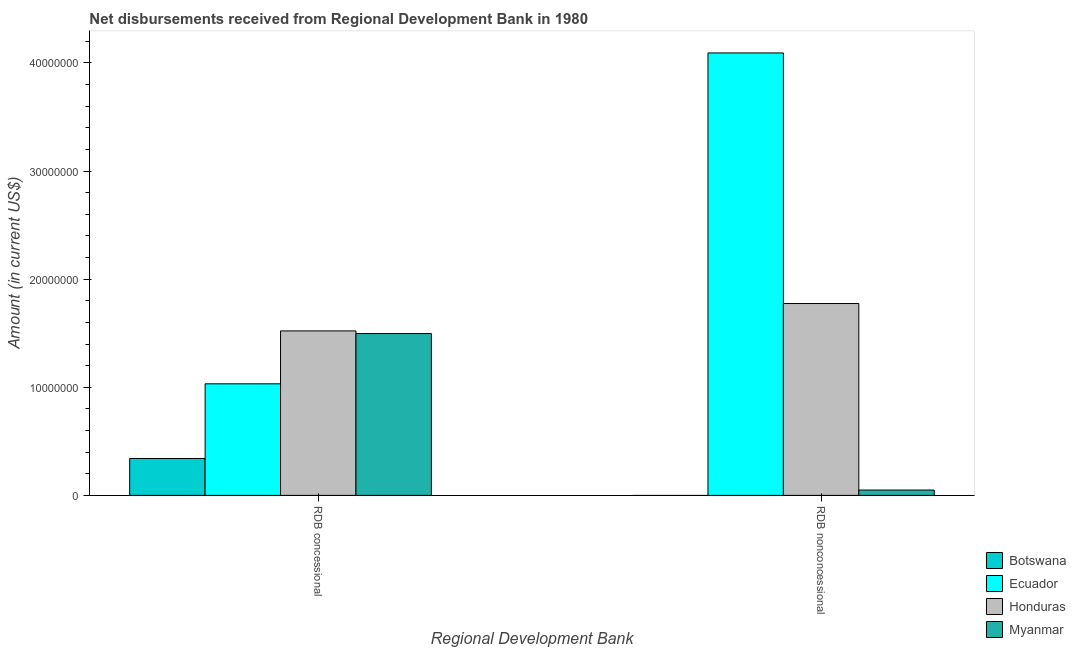How many bars are there on the 1st tick from the left?
Provide a short and direct response. 4. What is the label of the 2nd group of bars from the left?
Keep it short and to the point. RDB nonconcessional. What is the net concessional disbursements from rdb in Botswana?
Provide a succinct answer. 3.41e+06. Across all countries, what is the maximum net non concessional disbursements from rdb?
Your response must be concise. 4.09e+07. In which country was the net concessional disbursements from rdb maximum?
Ensure brevity in your answer.  Honduras. What is the total net concessional disbursements from rdb in the graph?
Make the answer very short. 4.39e+07. What is the difference between the net non concessional disbursements from rdb in Myanmar and that in Honduras?
Offer a very short reply. -1.72e+07. What is the difference between the net concessional disbursements from rdb in Botswana and the net non concessional disbursements from rdb in Ecuador?
Offer a very short reply. -3.75e+07. What is the average net non concessional disbursements from rdb per country?
Your response must be concise. 1.48e+07. What is the difference between the net concessional disbursements from rdb and net non concessional disbursements from rdb in Myanmar?
Your response must be concise. 1.45e+07. In how many countries, is the net concessional disbursements from rdb greater than 18000000 US$?
Your response must be concise. 0. What is the ratio of the net concessional disbursements from rdb in Ecuador to that in Myanmar?
Make the answer very short. 0.69. Is the net concessional disbursements from rdb in Botswana less than that in Ecuador?
Make the answer very short. Yes. How many bars are there?
Ensure brevity in your answer.  7. How many countries are there in the graph?
Give a very brief answer. 4. What is the difference between two consecutive major ticks on the Y-axis?
Provide a short and direct response. 1.00e+07. Where does the legend appear in the graph?
Your response must be concise. Bottom right. What is the title of the graph?
Offer a terse response. Net disbursements received from Regional Development Bank in 1980. Does "Zambia" appear as one of the legend labels in the graph?
Offer a terse response. No. What is the label or title of the X-axis?
Your response must be concise. Regional Development Bank. What is the Amount (in current US$) in Botswana in RDB concessional?
Make the answer very short. 3.41e+06. What is the Amount (in current US$) in Ecuador in RDB concessional?
Provide a succinct answer. 1.03e+07. What is the Amount (in current US$) in Honduras in RDB concessional?
Offer a terse response. 1.52e+07. What is the Amount (in current US$) of Myanmar in RDB concessional?
Your answer should be very brief. 1.50e+07. What is the Amount (in current US$) in Botswana in RDB nonconcessional?
Make the answer very short. 0. What is the Amount (in current US$) of Ecuador in RDB nonconcessional?
Offer a terse response. 4.09e+07. What is the Amount (in current US$) of Honduras in RDB nonconcessional?
Offer a very short reply. 1.77e+07. What is the Amount (in current US$) of Myanmar in RDB nonconcessional?
Your answer should be very brief. 4.94e+05. Across all Regional Development Bank, what is the maximum Amount (in current US$) in Botswana?
Offer a very short reply. 3.41e+06. Across all Regional Development Bank, what is the maximum Amount (in current US$) of Ecuador?
Give a very brief answer. 4.09e+07. Across all Regional Development Bank, what is the maximum Amount (in current US$) of Honduras?
Ensure brevity in your answer.  1.77e+07. Across all Regional Development Bank, what is the maximum Amount (in current US$) of Myanmar?
Ensure brevity in your answer.  1.50e+07. Across all Regional Development Bank, what is the minimum Amount (in current US$) in Ecuador?
Keep it short and to the point. 1.03e+07. Across all Regional Development Bank, what is the minimum Amount (in current US$) in Honduras?
Provide a succinct answer. 1.52e+07. Across all Regional Development Bank, what is the minimum Amount (in current US$) in Myanmar?
Your response must be concise. 4.94e+05. What is the total Amount (in current US$) in Botswana in the graph?
Your answer should be compact. 3.41e+06. What is the total Amount (in current US$) in Ecuador in the graph?
Ensure brevity in your answer.  5.12e+07. What is the total Amount (in current US$) of Honduras in the graph?
Your response must be concise. 3.30e+07. What is the total Amount (in current US$) in Myanmar in the graph?
Your answer should be compact. 1.55e+07. What is the difference between the Amount (in current US$) in Ecuador in RDB concessional and that in RDB nonconcessional?
Keep it short and to the point. -3.06e+07. What is the difference between the Amount (in current US$) in Honduras in RDB concessional and that in RDB nonconcessional?
Offer a terse response. -2.53e+06. What is the difference between the Amount (in current US$) of Myanmar in RDB concessional and that in RDB nonconcessional?
Provide a succinct answer. 1.45e+07. What is the difference between the Amount (in current US$) in Botswana in RDB concessional and the Amount (in current US$) in Ecuador in RDB nonconcessional?
Make the answer very short. -3.75e+07. What is the difference between the Amount (in current US$) of Botswana in RDB concessional and the Amount (in current US$) of Honduras in RDB nonconcessional?
Offer a very short reply. -1.43e+07. What is the difference between the Amount (in current US$) of Botswana in RDB concessional and the Amount (in current US$) of Myanmar in RDB nonconcessional?
Your response must be concise. 2.92e+06. What is the difference between the Amount (in current US$) of Ecuador in RDB concessional and the Amount (in current US$) of Honduras in RDB nonconcessional?
Provide a short and direct response. -7.43e+06. What is the difference between the Amount (in current US$) of Ecuador in RDB concessional and the Amount (in current US$) of Myanmar in RDB nonconcessional?
Provide a succinct answer. 9.82e+06. What is the difference between the Amount (in current US$) of Honduras in RDB concessional and the Amount (in current US$) of Myanmar in RDB nonconcessional?
Offer a terse response. 1.47e+07. What is the average Amount (in current US$) of Botswana per Regional Development Bank?
Give a very brief answer. 1.71e+06. What is the average Amount (in current US$) in Ecuador per Regional Development Bank?
Your response must be concise. 2.56e+07. What is the average Amount (in current US$) in Honduras per Regional Development Bank?
Offer a terse response. 1.65e+07. What is the average Amount (in current US$) in Myanmar per Regional Development Bank?
Your answer should be compact. 7.73e+06. What is the difference between the Amount (in current US$) in Botswana and Amount (in current US$) in Ecuador in RDB concessional?
Ensure brevity in your answer.  -6.91e+06. What is the difference between the Amount (in current US$) in Botswana and Amount (in current US$) in Honduras in RDB concessional?
Provide a succinct answer. -1.18e+07. What is the difference between the Amount (in current US$) in Botswana and Amount (in current US$) in Myanmar in RDB concessional?
Give a very brief answer. -1.16e+07. What is the difference between the Amount (in current US$) of Ecuador and Amount (in current US$) of Honduras in RDB concessional?
Your answer should be very brief. -4.89e+06. What is the difference between the Amount (in current US$) in Ecuador and Amount (in current US$) in Myanmar in RDB concessional?
Provide a succinct answer. -4.65e+06. What is the difference between the Amount (in current US$) of Honduras and Amount (in current US$) of Myanmar in RDB concessional?
Offer a very short reply. 2.43e+05. What is the difference between the Amount (in current US$) of Ecuador and Amount (in current US$) of Honduras in RDB nonconcessional?
Offer a very short reply. 2.32e+07. What is the difference between the Amount (in current US$) in Ecuador and Amount (in current US$) in Myanmar in RDB nonconcessional?
Offer a very short reply. 4.04e+07. What is the difference between the Amount (in current US$) in Honduras and Amount (in current US$) in Myanmar in RDB nonconcessional?
Offer a very short reply. 1.72e+07. What is the ratio of the Amount (in current US$) of Ecuador in RDB concessional to that in RDB nonconcessional?
Make the answer very short. 0.25. What is the ratio of the Amount (in current US$) of Honduras in RDB concessional to that in RDB nonconcessional?
Offer a terse response. 0.86. What is the ratio of the Amount (in current US$) of Myanmar in RDB concessional to that in RDB nonconcessional?
Offer a very short reply. 30.3. What is the difference between the highest and the second highest Amount (in current US$) of Ecuador?
Give a very brief answer. 3.06e+07. What is the difference between the highest and the second highest Amount (in current US$) in Honduras?
Offer a very short reply. 2.53e+06. What is the difference between the highest and the second highest Amount (in current US$) of Myanmar?
Make the answer very short. 1.45e+07. What is the difference between the highest and the lowest Amount (in current US$) of Botswana?
Your response must be concise. 3.41e+06. What is the difference between the highest and the lowest Amount (in current US$) in Ecuador?
Your answer should be very brief. 3.06e+07. What is the difference between the highest and the lowest Amount (in current US$) of Honduras?
Provide a succinct answer. 2.53e+06. What is the difference between the highest and the lowest Amount (in current US$) in Myanmar?
Offer a terse response. 1.45e+07. 